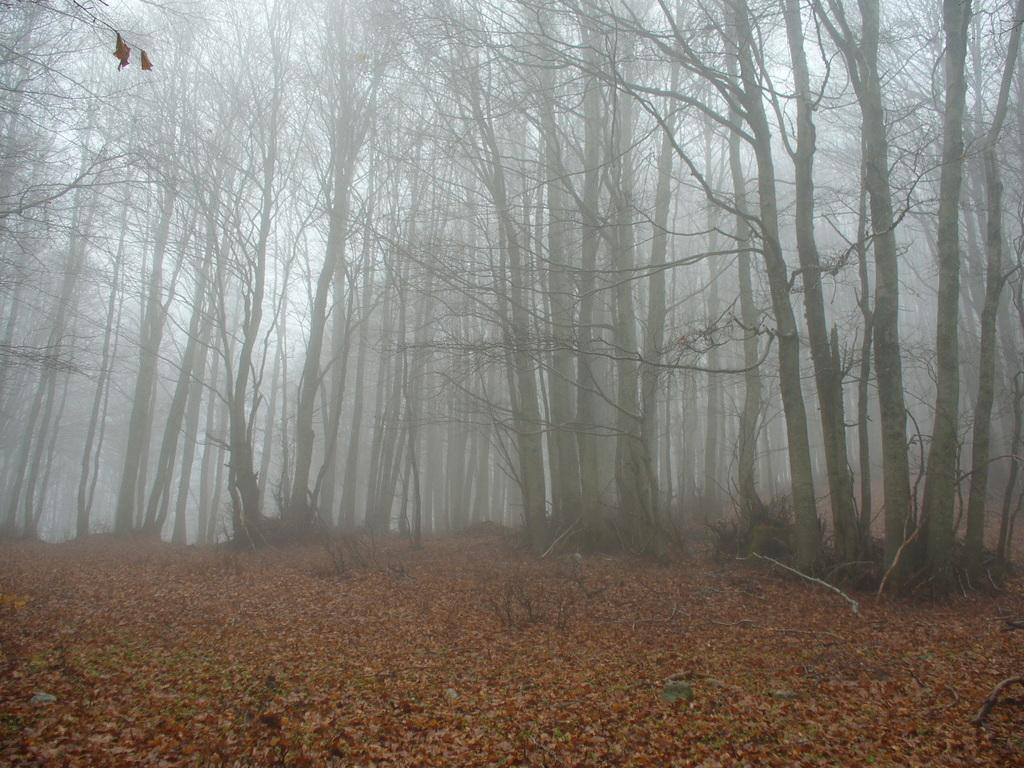What type of vegetation is in the middle of the image? There are tall trees in the middle of the image. What is present at the bottom of the image? There are dry leaves at the bottom of the image. What can be found on the ground in the image? There are wooden sticks on the ground in the image. How many bears are sitting on the tray in the image? There are no bears or trays present in the image. 